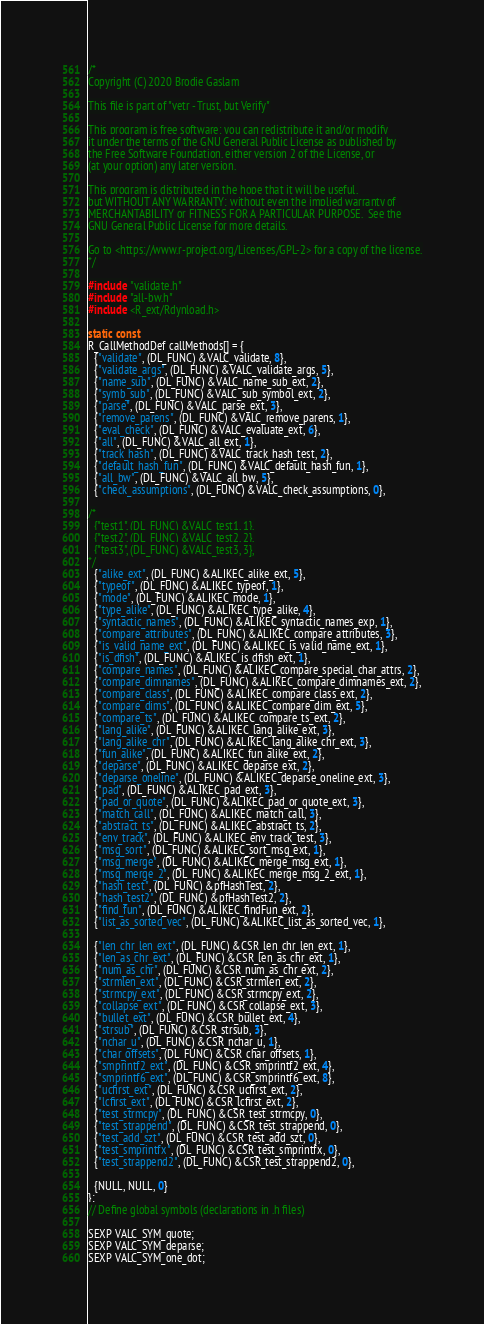<code> <loc_0><loc_0><loc_500><loc_500><_C_>/*
Copyright (C) 2020 Brodie Gaslam

This file is part of "vetr - Trust, but Verify"

This program is free software: you can redistribute it and/or modify
it under the terms of the GNU General Public License as published by
the Free Software Foundation, either version 2 of the License, or
(at your option) any later version.

This program is distributed in the hope that it will be useful,
but WITHOUT ANY WARRANTY; without even the implied warranty of
MERCHANTABILITY or FITNESS FOR A PARTICULAR PURPOSE.  See the
GNU General Public License for more details.

Go to <https://www.r-project.org/Licenses/GPL-2> for a copy of the license.
*/

#include "validate.h"
#include "all-bw.h"
#include <R_ext/Rdynload.h>

static const
R_CallMethodDef callMethods[] = {
  {"validate", (DL_FUNC) &VALC_validate, 8},
  {"validate_args", (DL_FUNC) &VALC_validate_args, 5},
  {"name_sub", (DL_FUNC) &VALC_name_sub_ext, 2},
  {"symb_sub", (DL_FUNC) &VALC_sub_symbol_ext, 2},
  {"parse", (DL_FUNC) &VALC_parse_ext, 3},
  {"remove_parens", (DL_FUNC) &VALC_remove_parens, 1},
  {"eval_check", (DL_FUNC) &VALC_evaluate_ext, 6},
  {"all", (DL_FUNC) &VALC_all_ext, 1},
  {"track_hash", (DL_FUNC) &VALC_track_hash_test, 2},
  {"default_hash_fun", (DL_FUNC) &VALC_default_hash_fun, 1},
  {"all_bw", (DL_FUNC) &VALC_all_bw, 5},
  {"check_assumptions", (DL_FUNC) &VALC_check_assumptions, 0},

/*
  {"test1", (DL_FUNC) &VALC_test1, 1},
  {"test2", (DL_FUNC) &VALC_test2, 2},
  {"test3", (DL_FUNC) &VALC_test3, 3},
*/
  {"alike_ext", (DL_FUNC) &ALIKEC_alike_ext, 5},
  {"typeof", (DL_FUNC) &ALIKEC_typeof, 1},
  {"mode", (DL_FUNC) &ALIKEC_mode, 1},
  {"type_alike", (DL_FUNC) &ALIKEC_type_alike, 4},
  {"syntactic_names", (DL_FUNC) &ALIKEC_syntactic_names_exp, 1},
  {"compare_attributes", (DL_FUNC) &ALIKEC_compare_attributes, 3},
  {"is_valid_name_ext", (DL_FUNC) &ALIKEC_is_valid_name_ext, 1},
  {"is_dfish", (DL_FUNC) &ALIKEC_is_dfish_ext, 1},
  {"compare_names", (DL_FUNC) &ALIKEC_compare_special_char_attrs, 2},
  {"compare_dimnames", (DL_FUNC) &ALIKEC_compare_dimnames_ext, 2},
  {"compare_class", (DL_FUNC) &ALIKEC_compare_class_ext, 2},
  {"compare_dims", (DL_FUNC) &ALIKEC_compare_dim_ext, 5},
  {"compare_ts", (DL_FUNC) &ALIKEC_compare_ts_ext, 2},
  {"lang_alike", (DL_FUNC) &ALIKEC_lang_alike_ext, 3},
  {"lang_alike_chr", (DL_FUNC) &ALIKEC_lang_alike_chr_ext, 3},
  {"fun_alike", (DL_FUNC) &ALIKEC_fun_alike_ext, 2},
  {"deparse", (DL_FUNC) &ALIKEC_deparse_ext, 2},
  {"deparse_oneline", (DL_FUNC) &ALIKEC_deparse_oneline_ext, 3},
  {"pad", (DL_FUNC) &ALIKEC_pad_ext, 3},
  {"pad_or_quote", (DL_FUNC) &ALIKEC_pad_or_quote_ext, 3},
  {"match_call", (DL_FUNC) &ALIKEC_match_call, 3},
  {"abstract_ts", (DL_FUNC) &ALIKEC_abstract_ts, 2},
  {"env_track", (DL_FUNC) &ALIKEC_env_track_test, 3},
  {"msg_sort", (DL_FUNC) &ALIKEC_sort_msg_ext, 1},
  {"msg_merge", (DL_FUNC) &ALIKEC_merge_msg_ext, 1},
  {"msg_merge_2", (DL_FUNC) &ALIKEC_merge_msg_2_ext, 1},
  {"hash_test", (DL_FUNC) &pfHashTest, 2},
  {"hash_test2", (DL_FUNC) &pfHashTest2, 2},
  {"find_fun", (DL_FUNC) &ALIKEC_findFun_ext, 2},
  {"list_as_sorted_vec", (DL_FUNC) &ALIKEC_list_as_sorted_vec, 1},

  {"len_chr_len_ext", (DL_FUNC) &CSR_len_chr_len_ext, 1},
  {"len_as_chr_ext", (DL_FUNC) &CSR_len_as_chr_ext, 1},
  {"num_as_chr", (DL_FUNC) &CSR_num_as_chr_ext, 2},
  {"strmlen_ext", (DL_FUNC) &CSR_strmlen_ext, 2},
  {"strmcpy_ext", (DL_FUNC) &CSR_strmcpy_ext, 2},
  {"collapse_ext", (DL_FUNC) &CSR_collapse_ext, 3},
  {"bullet_ext", (DL_FUNC) &CSR_bullet_ext, 4},
  {"strsub", (DL_FUNC) &CSR_strsub, 3},
  {"nchar_u", (DL_FUNC) &CSR_nchar_u, 1},
  {"char_offsets", (DL_FUNC) &CSR_char_offsets, 1},
  {"smprintf2_ext", (DL_FUNC) &CSR_smprintf2_ext, 4},
  {"smprintf6_ext", (DL_FUNC) &CSR_smprintf6_ext, 8},
  {"ucfirst_ext", (DL_FUNC) &CSR_ucfirst_ext, 2},
  {"lcfirst_ext", (DL_FUNC) &CSR_lcfirst_ext, 2},
  {"test_strmcpy", (DL_FUNC) &CSR_test_strmcpy, 0},
  {"test_strappend", (DL_FUNC) &CSR_test_strappend, 0},
  {"test_add_szt", (DL_FUNC) &CSR_test_add_szt, 0},
  {"test_smprintfx", (DL_FUNC) &CSR_test_smprintfx, 0},
  {"test_strappend2", (DL_FUNC) &CSR_test_strappend2, 0},

  {NULL, NULL, 0}
};
// Define global symbols (declarations in .h files)

SEXP VALC_SYM_quote;
SEXP VALC_SYM_deparse;
SEXP VALC_SYM_one_dot;</code> 